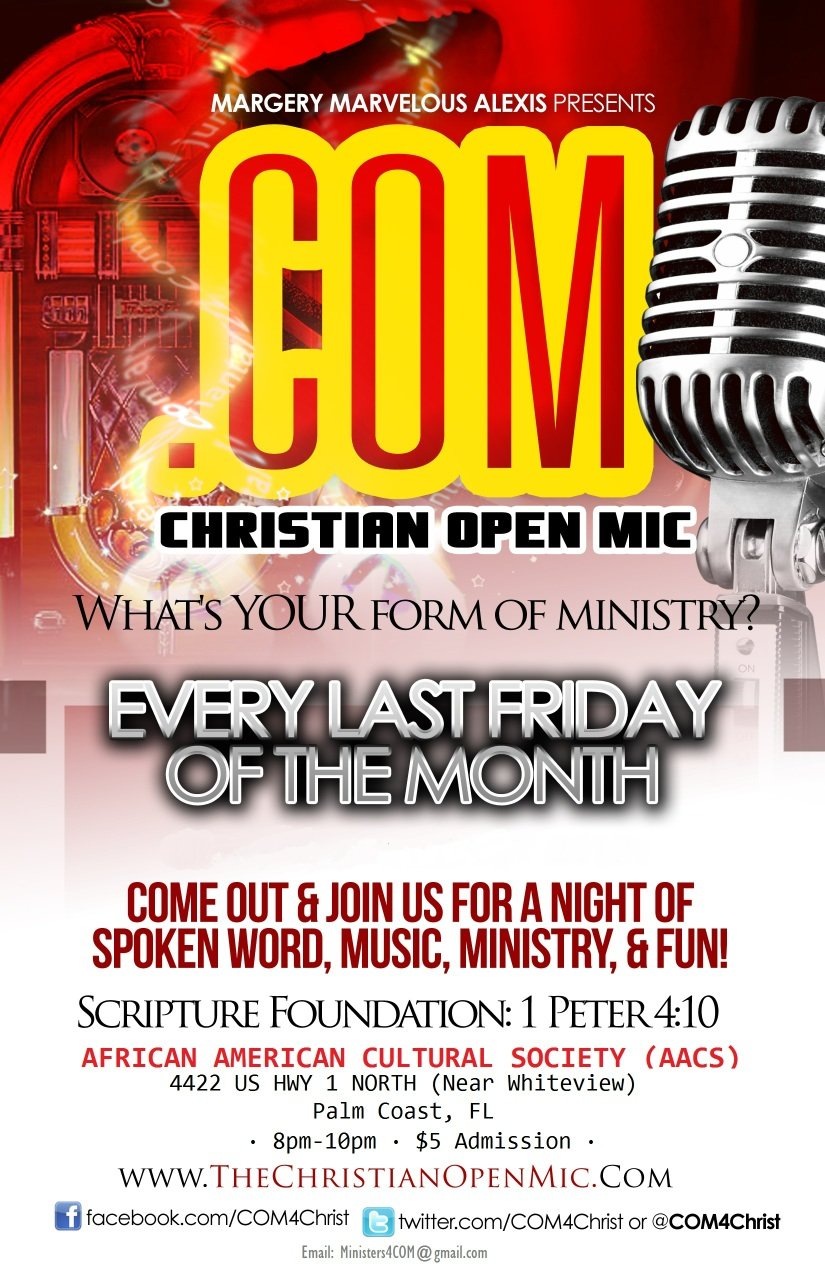Imagine a magical creature makes a surprise appearance at the open mic night. Describe the creature and how it reacts with the crowd. As the evening progresses, the room is suddenly illuminated by a warm, ethereal glow. A majestic creature, resembling a cross between a lion and an eagle with shimmering golden feathers and a mane that sparkles with iridescent light, appears on the stage. The crowd gasps in awe, sensing a divine presence. The creature begins to sing in a melodious, otherworldly voice that resonates with the deepest parts of everyone's souls, filling the venue with a sense of peace and joy. As it sings, the audience members feel their worries and burdens lift, replaced by hope and inspiration. Children approach the creature with wide-eyed wonder, and it gently interacts with them, sharing its radiant warmth. This heavenly visitor turns the night into an unforgettable experience, symbolizing the divine essence of the event and leaving a lasting impact on all who attend. 